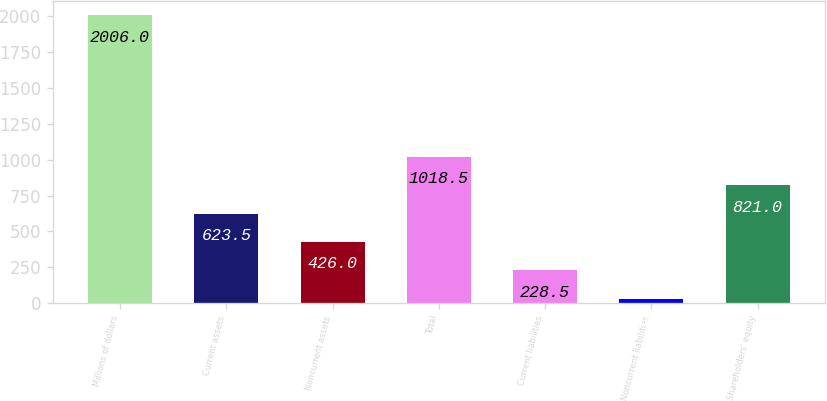Convert chart to OTSL. <chart><loc_0><loc_0><loc_500><loc_500><bar_chart><fcel>Millions of dollars<fcel>Current assets<fcel>Noncurrent assets<fcel>Total<fcel>Current liabilities<fcel>Noncurrent liabilities<fcel>Shareholders' equity<nl><fcel>2006<fcel>623.5<fcel>426<fcel>1018.5<fcel>228.5<fcel>31<fcel>821<nl></chart> 